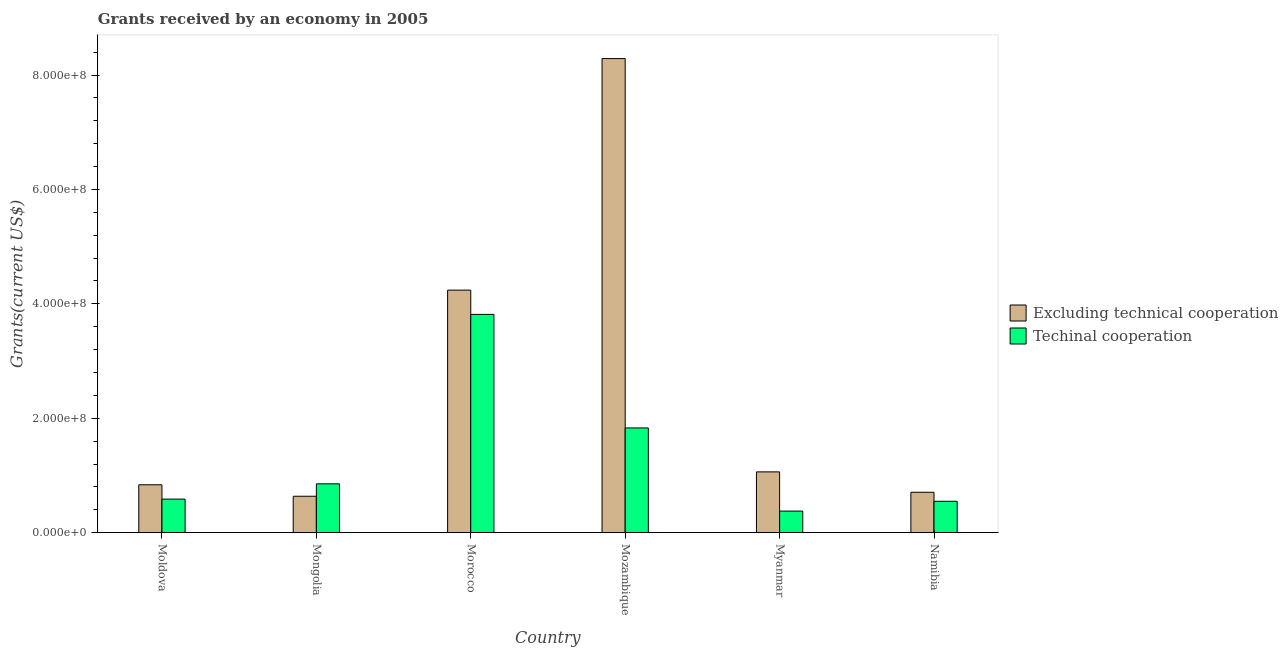How many bars are there on the 4th tick from the left?
Give a very brief answer. 2. What is the label of the 2nd group of bars from the left?
Your answer should be compact. Mongolia. In how many cases, is the number of bars for a given country not equal to the number of legend labels?
Ensure brevity in your answer.  0. What is the amount of grants received(excluding technical cooperation) in Myanmar?
Your answer should be compact. 1.06e+08. Across all countries, what is the maximum amount of grants received(excluding technical cooperation)?
Offer a very short reply. 8.29e+08. Across all countries, what is the minimum amount of grants received(including technical cooperation)?
Offer a very short reply. 3.78e+07. In which country was the amount of grants received(excluding technical cooperation) maximum?
Your answer should be very brief. Mozambique. In which country was the amount of grants received(including technical cooperation) minimum?
Provide a succinct answer. Myanmar. What is the total amount of grants received(excluding technical cooperation) in the graph?
Your answer should be compact. 1.58e+09. What is the difference between the amount of grants received(including technical cooperation) in Moldova and that in Namibia?
Your answer should be very brief. 3.79e+06. What is the difference between the amount of grants received(excluding technical cooperation) in Moldova and the amount of grants received(including technical cooperation) in Mozambique?
Offer a terse response. -9.94e+07. What is the average amount of grants received(excluding technical cooperation) per country?
Your answer should be very brief. 2.63e+08. What is the difference between the amount of grants received(excluding technical cooperation) and amount of grants received(including technical cooperation) in Mongolia?
Give a very brief answer. -2.17e+07. In how many countries, is the amount of grants received(excluding technical cooperation) greater than 80000000 US$?
Make the answer very short. 4. What is the ratio of the amount of grants received(including technical cooperation) in Mongolia to that in Myanmar?
Keep it short and to the point. 2.26. Is the amount of grants received(excluding technical cooperation) in Moldova less than that in Morocco?
Give a very brief answer. Yes. What is the difference between the highest and the second highest amount of grants received(excluding technical cooperation)?
Provide a succinct answer. 4.05e+08. What is the difference between the highest and the lowest amount of grants received(including technical cooperation)?
Offer a terse response. 3.44e+08. In how many countries, is the amount of grants received(excluding technical cooperation) greater than the average amount of grants received(excluding technical cooperation) taken over all countries?
Your answer should be compact. 2. Is the sum of the amount of grants received(excluding technical cooperation) in Mozambique and Namibia greater than the maximum amount of grants received(including technical cooperation) across all countries?
Offer a very short reply. Yes. What does the 1st bar from the left in Mozambique represents?
Your response must be concise. Excluding technical cooperation. What does the 1st bar from the right in Mongolia represents?
Offer a terse response. Techinal cooperation. How many bars are there?
Ensure brevity in your answer.  12. Are the values on the major ticks of Y-axis written in scientific E-notation?
Offer a terse response. Yes. Does the graph contain any zero values?
Keep it short and to the point. No. Does the graph contain grids?
Ensure brevity in your answer.  No. What is the title of the graph?
Your answer should be compact. Grants received by an economy in 2005. Does "Pregnant women" appear as one of the legend labels in the graph?
Provide a succinct answer. No. What is the label or title of the X-axis?
Give a very brief answer. Country. What is the label or title of the Y-axis?
Provide a short and direct response. Grants(current US$). What is the Grants(current US$) in Excluding technical cooperation in Moldova?
Make the answer very short. 8.38e+07. What is the Grants(current US$) of Techinal cooperation in Moldova?
Your answer should be very brief. 5.88e+07. What is the Grants(current US$) in Excluding technical cooperation in Mongolia?
Provide a succinct answer. 6.37e+07. What is the Grants(current US$) of Techinal cooperation in Mongolia?
Ensure brevity in your answer.  8.55e+07. What is the Grants(current US$) in Excluding technical cooperation in Morocco?
Your answer should be very brief. 4.24e+08. What is the Grants(current US$) in Techinal cooperation in Morocco?
Offer a terse response. 3.82e+08. What is the Grants(current US$) in Excluding technical cooperation in Mozambique?
Your response must be concise. 8.29e+08. What is the Grants(current US$) in Techinal cooperation in Mozambique?
Ensure brevity in your answer.  1.83e+08. What is the Grants(current US$) of Excluding technical cooperation in Myanmar?
Ensure brevity in your answer.  1.06e+08. What is the Grants(current US$) of Techinal cooperation in Myanmar?
Keep it short and to the point. 3.78e+07. What is the Grants(current US$) in Excluding technical cooperation in Namibia?
Make the answer very short. 7.07e+07. What is the Grants(current US$) in Techinal cooperation in Namibia?
Give a very brief answer. 5.50e+07. Across all countries, what is the maximum Grants(current US$) of Excluding technical cooperation?
Offer a very short reply. 8.29e+08. Across all countries, what is the maximum Grants(current US$) of Techinal cooperation?
Give a very brief answer. 3.82e+08. Across all countries, what is the minimum Grants(current US$) in Excluding technical cooperation?
Your answer should be compact. 6.37e+07. Across all countries, what is the minimum Grants(current US$) of Techinal cooperation?
Offer a very short reply. 3.78e+07. What is the total Grants(current US$) in Excluding technical cooperation in the graph?
Provide a short and direct response. 1.58e+09. What is the total Grants(current US$) of Techinal cooperation in the graph?
Ensure brevity in your answer.  8.02e+08. What is the difference between the Grants(current US$) in Excluding technical cooperation in Moldova and that in Mongolia?
Provide a short and direct response. 2.00e+07. What is the difference between the Grants(current US$) of Techinal cooperation in Moldova and that in Mongolia?
Offer a very short reply. -2.67e+07. What is the difference between the Grants(current US$) of Excluding technical cooperation in Moldova and that in Morocco?
Offer a terse response. -3.40e+08. What is the difference between the Grants(current US$) in Techinal cooperation in Moldova and that in Morocco?
Keep it short and to the point. -3.23e+08. What is the difference between the Grants(current US$) of Excluding technical cooperation in Moldova and that in Mozambique?
Make the answer very short. -7.45e+08. What is the difference between the Grants(current US$) in Techinal cooperation in Moldova and that in Mozambique?
Ensure brevity in your answer.  -1.24e+08. What is the difference between the Grants(current US$) of Excluding technical cooperation in Moldova and that in Myanmar?
Your answer should be very brief. -2.25e+07. What is the difference between the Grants(current US$) in Techinal cooperation in Moldova and that in Myanmar?
Your answer should be very brief. 2.10e+07. What is the difference between the Grants(current US$) in Excluding technical cooperation in Moldova and that in Namibia?
Give a very brief answer. 1.31e+07. What is the difference between the Grants(current US$) of Techinal cooperation in Moldova and that in Namibia?
Provide a short and direct response. 3.79e+06. What is the difference between the Grants(current US$) in Excluding technical cooperation in Mongolia and that in Morocco?
Your answer should be compact. -3.60e+08. What is the difference between the Grants(current US$) of Techinal cooperation in Mongolia and that in Morocco?
Keep it short and to the point. -2.96e+08. What is the difference between the Grants(current US$) in Excluding technical cooperation in Mongolia and that in Mozambique?
Offer a terse response. -7.65e+08. What is the difference between the Grants(current US$) of Techinal cooperation in Mongolia and that in Mozambique?
Give a very brief answer. -9.77e+07. What is the difference between the Grants(current US$) in Excluding technical cooperation in Mongolia and that in Myanmar?
Give a very brief answer. -4.26e+07. What is the difference between the Grants(current US$) of Techinal cooperation in Mongolia and that in Myanmar?
Your answer should be very brief. 4.77e+07. What is the difference between the Grants(current US$) of Excluding technical cooperation in Mongolia and that in Namibia?
Provide a succinct answer. -6.97e+06. What is the difference between the Grants(current US$) in Techinal cooperation in Mongolia and that in Namibia?
Offer a very short reply. 3.05e+07. What is the difference between the Grants(current US$) of Excluding technical cooperation in Morocco and that in Mozambique?
Your answer should be compact. -4.05e+08. What is the difference between the Grants(current US$) of Techinal cooperation in Morocco and that in Mozambique?
Make the answer very short. 1.98e+08. What is the difference between the Grants(current US$) of Excluding technical cooperation in Morocco and that in Myanmar?
Offer a very short reply. 3.18e+08. What is the difference between the Grants(current US$) of Techinal cooperation in Morocco and that in Myanmar?
Ensure brevity in your answer.  3.44e+08. What is the difference between the Grants(current US$) in Excluding technical cooperation in Morocco and that in Namibia?
Make the answer very short. 3.53e+08. What is the difference between the Grants(current US$) in Techinal cooperation in Morocco and that in Namibia?
Offer a very short reply. 3.27e+08. What is the difference between the Grants(current US$) of Excluding technical cooperation in Mozambique and that in Myanmar?
Keep it short and to the point. 7.22e+08. What is the difference between the Grants(current US$) of Techinal cooperation in Mozambique and that in Myanmar?
Ensure brevity in your answer.  1.45e+08. What is the difference between the Grants(current US$) in Excluding technical cooperation in Mozambique and that in Namibia?
Offer a terse response. 7.58e+08. What is the difference between the Grants(current US$) in Techinal cooperation in Mozambique and that in Namibia?
Provide a succinct answer. 1.28e+08. What is the difference between the Grants(current US$) in Excluding technical cooperation in Myanmar and that in Namibia?
Make the answer very short. 3.56e+07. What is the difference between the Grants(current US$) of Techinal cooperation in Myanmar and that in Namibia?
Offer a terse response. -1.72e+07. What is the difference between the Grants(current US$) of Excluding technical cooperation in Moldova and the Grants(current US$) of Techinal cooperation in Mongolia?
Make the answer very short. -1.68e+06. What is the difference between the Grants(current US$) of Excluding technical cooperation in Moldova and the Grants(current US$) of Techinal cooperation in Morocco?
Keep it short and to the point. -2.98e+08. What is the difference between the Grants(current US$) in Excluding technical cooperation in Moldova and the Grants(current US$) in Techinal cooperation in Mozambique?
Ensure brevity in your answer.  -9.94e+07. What is the difference between the Grants(current US$) in Excluding technical cooperation in Moldova and the Grants(current US$) in Techinal cooperation in Myanmar?
Ensure brevity in your answer.  4.60e+07. What is the difference between the Grants(current US$) of Excluding technical cooperation in Moldova and the Grants(current US$) of Techinal cooperation in Namibia?
Your response must be concise. 2.88e+07. What is the difference between the Grants(current US$) of Excluding technical cooperation in Mongolia and the Grants(current US$) of Techinal cooperation in Morocco?
Your answer should be compact. -3.18e+08. What is the difference between the Grants(current US$) in Excluding technical cooperation in Mongolia and the Grants(current US$) in Techinal cooperation in Mozambique?
Your answer should be very brief. -1.19e+08. What is the difference between the Grants(current US$) in Excluding technical cooperation in Mongolia and the Grants(current US$) in Techinal cooperation in Myanmar?
Your answer should be compact. 2.59e+07. What is the difference between the Grants(current US$) of Excluding technical cooperation in Mongolia and the Grants(current US$) of Techinal cooperation in Namibia?
Ensure brevity in your answer.  8.77e+06. What is the difference between the Grants(current US$) in Excluding technical cooperation in Morocco and the Grants(current US$) in Techinal cooperation in Mozambique?
Your answer should be very brief. 2.41e+08. What is the difference between the Grants(current US$) in Excluding technical cooperation in Morocco and the Grants(current US$) in Techinal cooperation in Myanmar?
Provide a succinct answer. 3.86e+08. What is the difference between the Grants(current US$) in Excluding technical cooperation in Morocco and the Grants(current US$) in Techinal cooperation in Namibia?
Your answer should be very brief. 3.69e+08. What is the difference between the Grants(current US$) of Excluding technical cooperation in Mozambique and the Grants(current US$) of Techinal cooperation in Myanmar?
Provide a succinct answer. 7.91e+08. What is the difference between the Grants(current US$) in Excluding technical cooperation in Mozambique and the Grants(current US$) in Techinal cooperation in Namibia?
Your answer should be compact. 7.74e+08. What is the difference between the Grants(current US$) of Excluding technical cooperation in Myanmar and the Grants(current US$) of Techinal cooperation in Namibia?
Ensure brevity in your answer.  5.14e+07. What is the average Grants(current US$) of Excluding technical cooperation per country?
Your answer should be compact. 2.63e+08. What is the average Grants(current US$) in Techinal cooperation per country?
Give a very brief answer. 1.34e+08. What is the difference between the Grants(current US$) in Excluding technical cooperation and Grants(current US$) in Techinal cooperation in Moldova?
Make the answer very short. 2.50e+07. What is the difference between the Grants(current US$) in Excluding technical cooperation and Grants(current US$) in Techinal cooperation in Mongolia?
Your answer should be compact. -2.17e+07. What is the difference between the Grants(current US$) of Excluding technical cooperation and Grants(current US$) of Techinal cooperation in Morocco?
Your answer should be very brief. 4.24e+07. What is the difference between the Grants(current US$) in Excluding technical cooperation and Grants(current US$) in Techinal cooperation in Mozambique?
Your answer should be compact. 6.46e+08. What is the difference between the Grants(current US$) of Excluding technical cooperation and Grants(current US$) of Techinal cooperation in Myanmar?
Make the answer very short. 6.85e+07. What is the difference between the Grants(current US$) in Excluding technical cooperation and Grants(current US$) in Techinal cooperation in Namibia?
Provide a short and direct response. 1.57e+07. What is the ratio of the Grants(current US$) of Excluding technical cooperation in Moldova to that in Mongolia?
Ensure brevity in your answer.  1.31. What is the ratio of the Grants(current US$) in Techinal cooperation in Moldova to that in Mongolia?
Give a very brief answer. 0.69. What is the ratio of the Grants(current US$) of Excluding technical cooperation in Moldova to that in Morocco?
Your response must be concise. 0.2. What is the ratio of the Grants(current US$) in Techinal cooperation in Moldova to that in Morocco?
Your answer should be very brief. 0.15. What is the ratio of the Grants(current US$) of Excluding technical cooperation in Moldova to that in Mozambique?
Ensure brevity in your answer.  0.1. What is the ratio of the Grants(current US$) in Techinal cooperation in Moldova to that in Mozambique?
Your response must be concise. 0.32. What is the ratio of the Grants(current US$) in Excluding technical cooperation in Moldova to that in Myanmar?
Keep it short and to the point. 0.79. What is the ratio of the Grants(current US$) of Techinal cooperation in Moldova to that in Myanmar?
Your response must be concise. 1.55. What is the ratio of the Grants(current US$) of Excluding technical cooperation in Moldova to that in Namibia?
Provide a succinct answer. 1.19. What is the ratio of the Grants(current US$) in Techinal cooperation in Moldova to that in Namibia?
Make the answer very short. 1.07. What is the ratio of the Grants(current US$) in Excluding technical cooperation in Mongolia to that in Morocco?
Your answer should be very brief. 0.15. What is the ratio of the Grants(current US$) of Techinal cooperation in Mongolia to that in Morocco?
Keep it short and to the point. 0.22. What is the ratio of the Grants(current US$) of Excluding technical cooperation in Mongolia to that in Mozambique?
Give a very brief answer. 0.08. What is the ratio of the Grants(current US$) in Techinal cooperation in Mongolia to that in Mozambique?
Give a very brief answer. 0.47. What is the ratio of the Grants(current US$) in Excluding technical cooperation in Mongolia to that in Myanmar?
Your answer should be compact. 0.6. What is the ratio of the Grants(current US$) of Techinal cooperation in Mongolia to that in Myanmar?
Ensure brevity in your answer.  2.26. What is the ratio of the Grants(current US$) in Excluding technical cooperation in Mongolia to that in Namibia?
Provide a succinct answer. 0.9. What is the ratio of the Grants(current US$) of Techinal cooperation in Mongolia to that in Namibia?
Provide a succinct answer. 1.55. What is the ratio of the Grants(current US$) in Excluding technical cooperation in Morocco to that in Mozambique?
Offer a terse response. 0.51. What is the ratio of the Grants(current US$) in Techinal cooperation in Morocco to that in Mozambique?
Your answer should be very brief. 2.08. What is the ratio of the Grants(current US$) in Excluding technical cooperation in Morocco to that in Myanmar?
Offer a terse response. 3.99. What is the ratio of the Grants(current US$) of Techinal cooperation in Morocco to that in Myanmar?
Keep it short and to the point. 10.1. What is the ratio of the Grants(current US$) of Excluding technical cooperation in Morocco to that in Namibia?
Your answer should be very brief. 6. What is the ratio of the Grants(current US$) in Techinal cooperation in Morocco to that in Namibia?
Provide a short and direct response. 6.94. What is the ratio of the Grants(current US$) in Excluding technical cooperation in Mozambique to that in Myanmar?
Your response must be concise. 7.79. What is the ratio of the Grants(current US$) in Techinal cooperation in Mozambique to that in Myanmar?
Give a very brief answer. 4.85. What is the ratio of the Grants(current US$) in Excluding technical cooperation in Mozambique to that in Namibia?
Give a very brief answer. 11.72. What is the ratio of the Grants(current US$) of Techinal cooperation in Mozambique to that in Namibia?
Give a very brief answer. 3.33. What is the ratio of the Grants(current US$) of Excluding technical cooperation in Myanmar to that in Namibia?
Provide a short and direct response. 1.5. What is the ratio of the Grants(current US$) of Techinal cooperation in Myanmar to that in Namibia?
Provide a succinct answer. 0.69. What is the difference between the highest and the second highest Grants(current US$) in Excluding technical cooperation?
Your answer should be very brief. 4.05e+08. What is the difference between the highest and the second highest Grants(current US$) in Techinal cooperation?
Provide a short and direct response. 1.98e+08. What is the difference between the highest and the lowest Grants(current US$) of Excluding technical cooperation?
Ensure brevity in your answer.  7.65e+08. What is the difference between the highest and the lowest Grants(current US$) in Techinal cooperation?
Your response must be concise. 3.44e+08. 